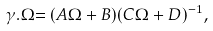Convert formula to latex. <formula><loc_0><loc_0><loc_500><loc_500>\gamma . \Omega { = ( A \Omega + B ) ( C \Omega + D ) ^ { - 1 } , }</formula> 